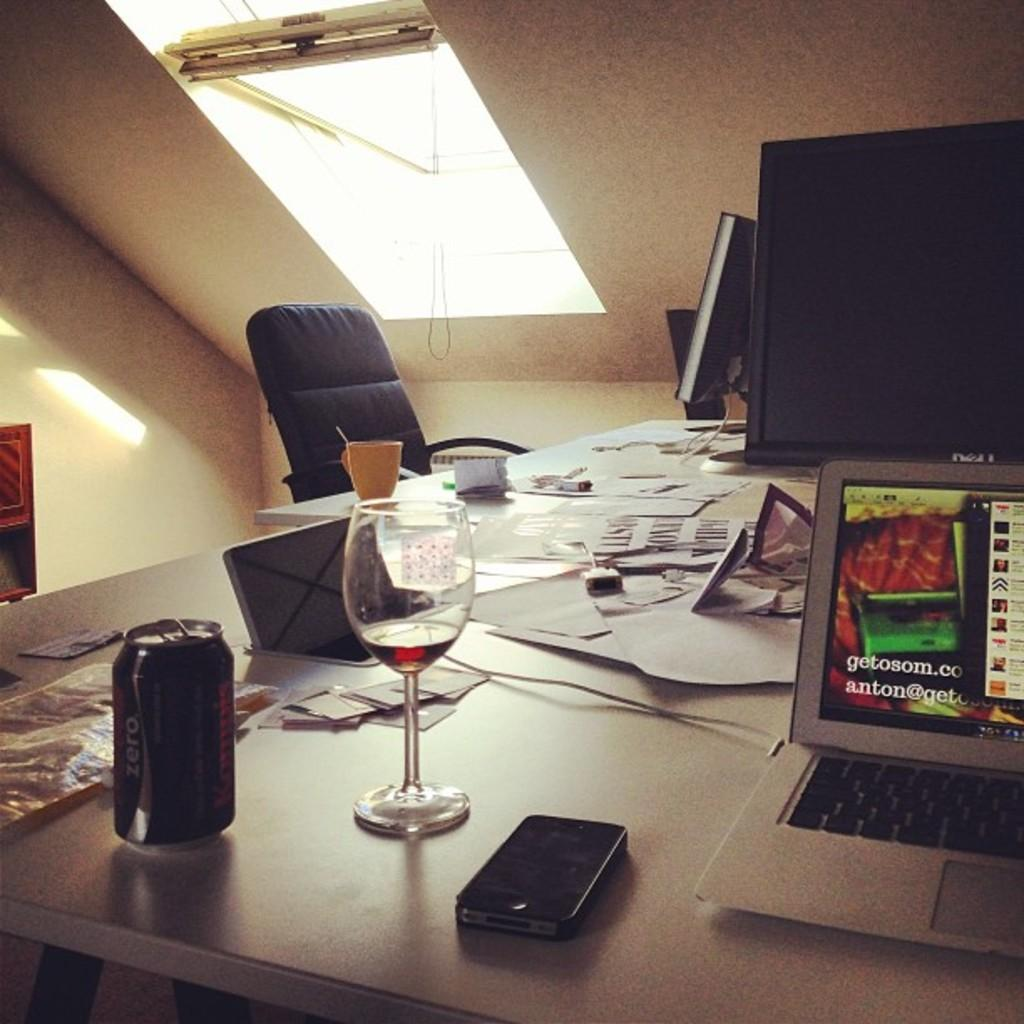What objects are on the table in the image? There are papers, a glass, a cup, a laptop, and monitors on the table in the image. What type of container is on the table? There is a glass and a cup on the table. What electronic device is on the table? A laptop is present on the table. How many monitors are on the table? There are monitors on the table. What is the person sitting in front of the table using? There is a chair in front of the table, but the image does not show what the person is using. What type of lighting is present in the image? There is a light in the image. What can be seen in the background of the image? There is a wall in the background of the image. What type of fish can be seen swimming in the glass on the table? There is no fish present in the glass on the table; it contains a liquid, likely water or a beverage. What type of fang can be seen on the chair in the image? There are no fangs present in the image; the chair is a regular chair without any animal or creature features. 